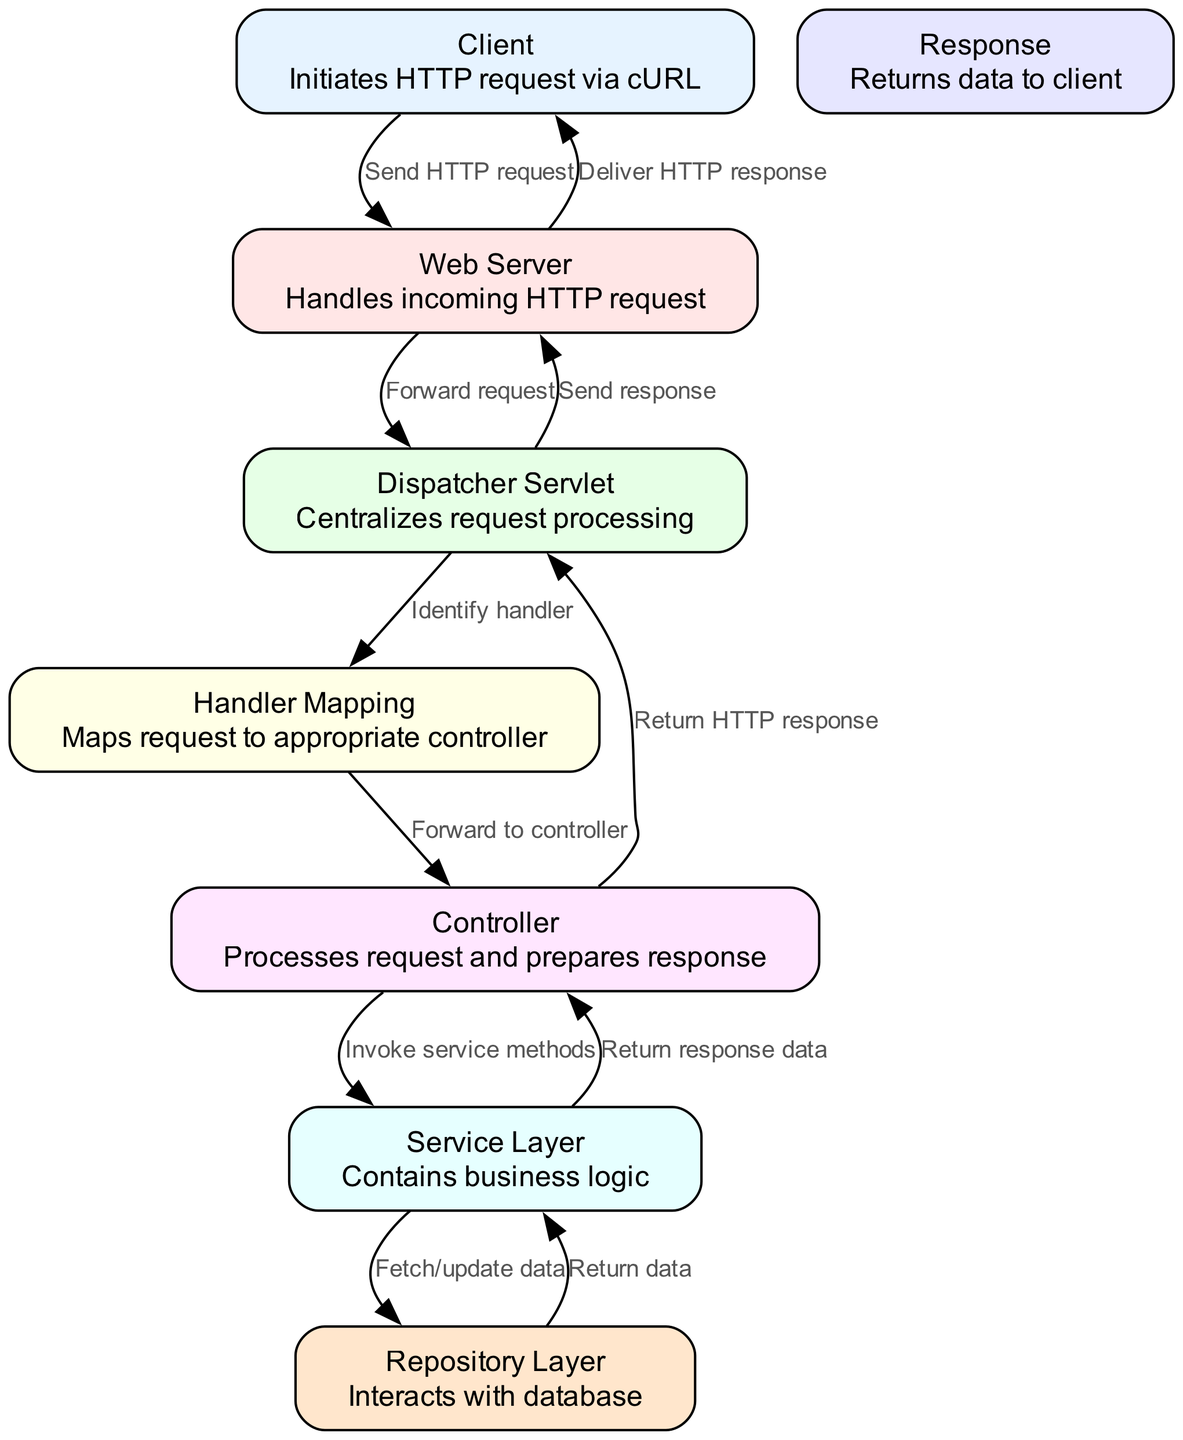What is the starting point of the diagram? The starting point is the "Client" node which initiates the HTTP request via cURL. This is the first node in the lifecycle shown in the diagram, indicating where the HTTP request originates.
Answer: Client How many nodes are there in the diagram? By counting the "nodes" section in the data, we find there are eight nodes including the client, web server, dispatcher servlet, handler mapping, controller, service layer, repository layer, and response.
Answer: 8 What is the label of the node that handles incoming HTTP requests? The node responsible for handling incoming HTTP requests is labeled as "Web Server." It is directly connected to the "Client" indicating it processes requests sent by the client.
Answer: Web Server Which node is responsible for processing the request after handler mapping? The "Controller" node is responsible for processing the request after it is mapped by the "Handler Mapping." The flow shows that the handler mapping forwards to the controller for further processing.
Answer: Controller What layer does the service layer interact with to fetch/update data? The service layer interacts with the "Repository Layer" to fetch or update data. The edge labeled "Fetch/update data" shows this interaction directing from service layer to repository layer.
Answer: Repository Layer What is the final destination of the HTTP response in the diagram? The final destination of the HTTP response is the "Client." The flow indicates that the response is sent back from the web server to the client, marking the completion of the HTTP request lifecycle.
Answer: Client Which node forwards requests to the controller? The "Handler Mapping" node forwards requests to the "Controller" node. This relationship is established in the diagram where the arrow indicates that the handler mapping identifies the appropriate controller for the request.
Answer: Handler Mapping How many edges connect the controller to the service layer? There is only one edge connecting the "Controller" to the "Service Layer," as indicated in the diagram where the controller invokes service methods capturing the request processing flow.
Answer: 1 